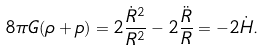<formula> <loc_0><loc_0><loc_500><loc_500>8 \pi G ( \rho + p ) = 2 \frac { \dot { R } ^ { 2 } } { R ^ { 2 } } - 2 \frac { \ddot { R } } { R } = - 2 \dot { H } .</formula> 